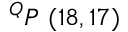<formula> <loc_0><loc_0><loc_500><loc_500>^ { Q } P \ ( 1 8 , 1 7 )</formula> 